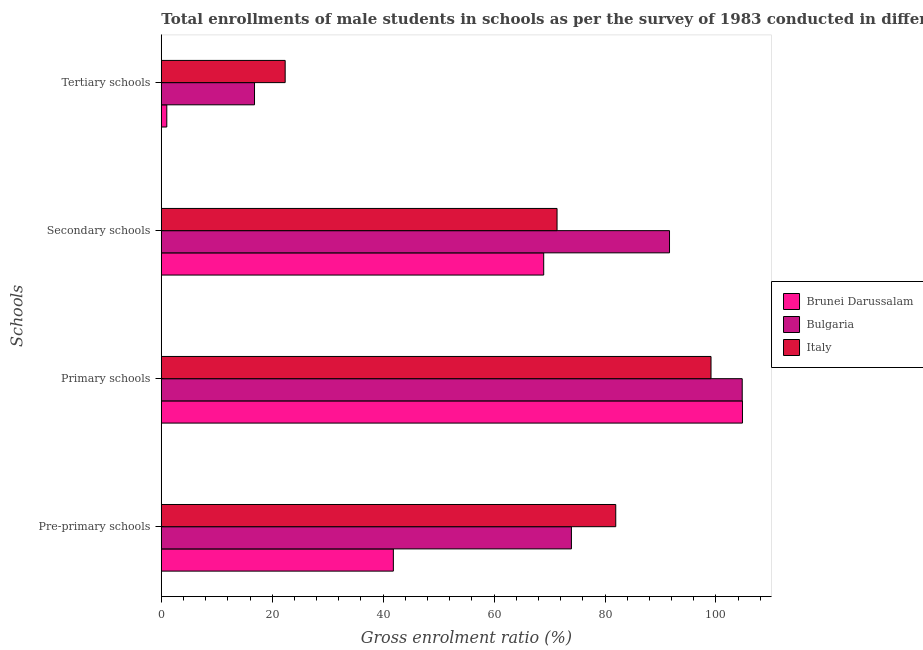Are the number of bars per tick equal to the number of legend labels?
Give a very brief answer. Yes. Are the number of bars on each tick of the Y-axis equal?
Your answer should be compact. Yes. How many bars are there on the 4th tick from the top?
Provide a short and direct response. 3. What is the label of the 4th group of bars from the top?
Your response must be concise. Pre-primary schools. What is the gross enrolment ratio(male) in tertiary schools in Brunei Darussalam?
Your response must be concise. 0.99. Across all countries, what is the maximum gross enrolment ratio(male) in pre-primary schools?
Make the answer very short. 81.93. Across all countries, what is the minimum gross enrolment ratio(male) in primary schools?
Your response must be concise. 99.11. In which country was the gross enrolment ratio(male) in primary schools maximum?
Your response must be concise. Brunei Darussalam. In which country was the gross enrolment ratio(male) in tertiary schools minimum?
Offer a very short reply. Brunei Darussalam. What is the total gross enrolment ratio(male) in tertiary schools in the graph?
Provide a succinct answer. 40.12. What is the difference between the gross enrolment ratio(male) in secondary schools in Brunei Darussalam and that in Bulgaria?
Provide a short and direct response. -22.68. What is the difference between the gross enrolment ratio(male) in primary schools in Brunei Darussalam and the gross enrolment ratio(male) in pre-primary schools in Bulgaria?
Your response must be concise. 30.84. What is the average gross enrolment ratio(male) in tertiary schools per country?
Offer a very short reply. 13.37. What is the difference between the gross enrolment ratio(male) in pre-primary schools and gross enrolment ratio(male) in secondary schools in Bulgaria?
Keep it short and to the point. -17.69. What is the ratio of the gross enrolment ratio(male) in tertiary schools in Brunei Darussalam to that in Bulgaria?
Your response must be concise. 0.06. What is the difference between the highest and the second highest gross enrolment ratio(male) in secondary schools?
Keep it short and to the point. 20.28. What is the difference between the highest and the lowest gross enrolment ratio(male) in primary schools?
Ensure brevity in your answer.  5.67. What does the 1st bar from the top in Pre-primary schools represents?
Provide a succinct answer. Italy. Is it the case that in every country, the sum of the gross enrolment ratio(male) in pre-primary schools and gross enrolment ratio(male) in primary schools is greater than the gross enrolment ratio(male) in secondary schools?
Offer a terse response. Yes. Are all the bars in the graph horizontal?
Provide a short and direct response. Yes. How many legend labels are there?
Offer a terse response. 3. What is the title of the graph?
Give a very brief answer. Total enrollments of male students in schools as per the survey of 1983 conducted in different countries. Does "Portugal" appear as one of the legend labels in the graph?
Offer a very short reply. No. What is the label or title of the Y-axis?
Your answer should be compact. Schools. What is the Gross enrolment ratio (%) of Brunei Darussalam in Pre-primary schools?
Provide a succinct answer. 41.84. What is the Gross enrolment ratio (%) of Bulgaria in Pre-primary schools?
Keep it short and to the point. 73.94. What is the Gross enrolment ratio (%) of Italy in Pre-primary schools?
Your answer should be very brief. 81.93. What is the Gross enrolment ratio (%) in Brunei Darussalam in Primary schools?
Give a very brief answer. 104.77. What is the Gross enrolment ratio (%) of Bulgaria in Primary schools?
Offer a terse response. 104.73. What is the Gross enrolment ratio (%) in Italy in Primary schools?
Make the answer very short. 99.11. What is the Gross enrolment ratio (%) in Brunei Darussalam in Secondary schools?
Ensure brevity in your answer.  68.94. What is the Gross enrolment ratio (%) of Bulgaria in Secondary schools?
Provide a succinct answer. 91.63. What is the Gross enrolment ratio (%) in Italy in Secondary schools?
Provide a succinct answer. 71.35. What is the Gross enrolment ratio (%) in Brunei Darussalam in Tertiary schools?
Your answer should be compact. 0.99. What is the Gross enrolment ratio (%) in Bulgaria in Tertiary schools?
Give a very brief answer. 16.8. What is the Gross enrolment ratio (%) in Italy in Tertiary schools?
Make the answer very short. 22.33. Across all Schools, what is the maximum Gross enrolment ratio (%) in Brunei Darussalam?
Give a very brief answer. 104.77. Across all Schools, what is the maximum Gross enrolment ratio (%) of Bulgaria?
Your response must be concise. 104.73. Across all Schools, what is the maximum Gross enrolment ratio (%) of Italy?
Make the answer very short. 99.11. Across all Schools, what is the minimum Gross enrolment ratio (%) in Brunei Darussalam?
Provide a succinct answer. 0.99. Across all Schools, what is the minimum Gross enrolment ratio (%) of Bulgaria?
Provide a short and direct response. 16.8. Across all Schools, what is the minimum Gross enrolment ratio (%) of Italy?
Keep it short and to the point. 22.33. What is the total Gross enrolment ratio (%) of Brunei Darussalam in the graph?
Offer a very short reply. 216.54. What is the total Gross enrolment ratio (%) in Bulgaria in the graph?
Give a very brief answer. 287.1. What is the total Gross enrolment ratio (%) of Italy in the graph?
Give a very brief answer. 274.72. What is the difference between the Gross enrolment ratio (%) in Brunei Darussalam in Pre-primary schools and that in Primary schools?
Offer a terse response. -62.94. What is the difference between the Gross enrolment ratio (%) in Bulgaria in Pre-primary schools and that in Primary schools?
Your response must be concise. -30.79. What is the difference between the Gross enrolment ratio (%) in Italy in Pre-primary schools and that in Primary schools?
Offer a very short reply. -17.18. What is the difference between the Gross enrolment ratio (%) of Brunei Darussalam in Pre-primary schools and that in Secondary schools?
Give a very brief answer. -27.1. What is the difference between the Gross enrolment ratio (%) in Bulgaria in Pre-primary schools and that in Secondary schools?
Offer a terse response. -17.69. What is the difference between the Gross enrolment ratio (%) of Italy in Pre-primary schools and that in Secondary schools?
Keep it short and to the point. 10.58. What is the difference between the Gross enrolment ratio (%) of Brunei Darussalam in Pre-primary schools and that in Tertiary schools?
Offer a very short reply. 40.85. What is the difference between the Gross enrolment ratio (%) of Bulgaria in Pre-primary schools and that in Tertiary schools?
Make the answer very short. 57.14. What is the difference between the Gross enrolment ratio (%) of Italy in Pre-primary schools and that in Tertiary schools?
Keep it short and to the point. 59.6. What is the difference between the Gross enrolment ratio (%) of Brunei Darussalam in Primary schools and that in Secondary schools?
Provide a succinct answer. 35.83. What is the difference between the Gross enrolment ratio (%) of Bulgaria in Primary schools and that in Secondary schools?
Give a very brief answer. 13.11. What is the difference between the Gross enrolment ratio (%) in Italy in Primary schools and that in Secondary schools?
Ensure brevity in your answer.  27.76. What is the difference between the Gross enrolment ratio (%) in Brunei Darussalam in Primary schools and that in Tertiary schools?
Offer a terse response. 103.79. What is the difference between the Gross enrolment ratio (%) of Bulgaria in Primary schools and that in Tertiary schools?
Your response must be concise. 87.93. What is the difference between the Gross enrolment ratio (%) of Italy in Primary schools and that in Tertiary schools?
Your answer should be compact. 76.78. What is the difference between the Gross enrolment ratio (%) of Brunei Darussalam in Secondary schools and that in Tertiary schools?
Provide a succinct answer. 67.95. What is the difference between the Gross enrolment ratio (%) in Bulgaria in Secondary schools and that in Tertiary schools?
Your response must be concise. 74.82. What is the difference between the Gross enrolment ratio (%) in Italy in Secondary schools and that in Tertiary schools?
Provide a short and direct response. 49.02. What is the difference between the Gross enrolment ratio (%) of Brunei Darussalam in Pre-primary schools and the Gross enrolment ratio (%) of Bulgaria in Primary schools?
Your answer should be compact. -62.9. What is the difference between the Gross enrolment ratio (%) of Brunei Darussalam in Pre-primary schools and the Gross enrolment ratio (%) of Italy in Primary schools?
Offer a terse response. -57.27. What is the difference between the Gross enrolment ratio (%) in Bulgaria in Pre-primary schools and the Gross enrolment ratio (%) in Italy in Primary schools?
Provide a short and direct response. -25.17. What is the difference between the Gross enrolment ratio (%) of Brunei Darussalam in Pre-primary schools and the Gross enrolment ratio (%) of Bulgaria in Secondary schools?
Your response must be concise. -49.79. What is the difference between the Gross enrolment ratio (%) of Brunei Darussalam in Pre-primary schools and the Gross enrolment ratio (%) of Italy in Secondary schools?
Your answer should be very brief. -29.51. What is the difference between the Gross enrolment ratio (%) in Bulgaria in Pre-primary schools and the Gross enrolment ratio (%) in Italy in Secondary schools?
Offer a very short reply. 2.59. What is the difference between the Gross enrolment ratio (%) of Brunei Darussalam in Pre-primary schools and the Gross enrolment ratio (%) of Bulgaria in Tertiary schools?
Provide a succinct answer. 25.03. What is the difference between the Gross enrolment ratio (%) of Brunei Darussalam in Pre-primary schools and the Gross enrolment ratio (%) of Italy in Tertiary schools?
Provide a succinct answer. 19.51. What is the difference between the Gross enrolment ratio (%) of Bulgaria in Pre-primary schools and the Gross enrolment ratio (%) of Italy in Tertiary schools?
Provide a short and direct response. 51.61. What is the difference between the Gross enrolment ratio (%) in Brunei Darussalam in Primary schools and the Gross enrolment ratio (%) in Bulgaria in Secondary schools?
Ensure brevity in your answer.  13.15. What is the difference between the Gross enrolment ratio (%) in Brunei Darussalam in Primary schools and the Gross enrolment ratio (%) in Italy in Secondary schools?
Provide a succinct answer. 33.43. What is the difference between the Gross enrolment ratio (%) in Bulgaria in Primary schools and the Gross enrolment ratio (%) in Italy in Secondary schools?
Your answer should be very brief. 33.38. What is the difference between the Gross enrolment ratio (%) in Brunei Darussalam in Primary schools and the Gross enrolment ratio (%) in Bulgaria in Tertiary schools?
Give a very brief answer. 87.97. What is the difference between the Gross enrolment ratio (%) in Brunei Darussalam in Primary schools and the Gross enrolment ratio (%) in Italy in Tertiary schools?
Give a very brief answer. 82.44. What is the difference between the Gross enrolment ratio (%) of Bulgaria in Primary schools and the Gross enrolment ratio (%) of Italy in Tertiary schools?
Your answer should be very brief. 82.4. What is the difference between the Gross enrolment ratio (%) of Brunei Darussalam in Secondary schools and the Gross enrolment ratio (%) of Bulgaria in Tertiary schools?
Keep it short and to the point. 52.14. What is the difference between the Gross enrolment ratio (%) of Brunei Darussalam in Secondary schools and the Gross enrolment ratio (%) of Italy in Tertiary schools?
Offer a very short reply. 46.61. What is the difference between the Gross enrolment ratio (%) in Bulgaria in Secondary schools and the Gross enrolment ratio (%) in Italy in Tertiary schools?
Provide a succinct answer. 69.29. What is the average Gross enrolment ratio (%) of Brunei Darussalam per Schools?
Your response must be concise. 54.14. What is the average Gross enrolment ratio (%) of Bulgaria per Schools?
Provide a short and direct response. 71.78. What is the average Gross enrolment ratio (%) in Italy per Schools?
Provide a succinct answer. 68.68. What is the difference between the Gross enrolment ratio (%) in Brunei Darussalam and Gross enrolment ratio (%) in Bulgaria in Pre-primary schools?
Make the answer very short. -32.1. What is the difference between the Gross enrolment ratio (%) in Brunei Darussalam and Gross enrolment ratio (%) in Italy in Pre-primary schools?
Ensure brevity in your answer.  -40.09. What is the difference between the Gross enrolment ratio (%) of Bulgaria and Gross enrolment ratio (%) of Italy in Pre-primary schools?
Provide a succinct answer. -7.99. What is the difference between the Gross enrolment ratio (%) in Brunei Darussalam and Gross enrolment ratio (%) in Bulgaria in Primary schools?
Keep it short and to the point. 0.04. What is the difference between the Gross enrolment ratio (%) of Brunei Darussalam and Gross enrolment ratio (%) of Italy in Primary schools?
Ensure brevity in your answer.  5.67. What is the difference between the Gross enrolment ratio (%) in Bulgaria and Gross enrolment ratio (%) in Italy in Primary schools?
Offer a very short reply. 5.63. What is the difference between the Gross enrolment ratio (%) in Brunei Darussalam and Gross enrolment ratio (%) in Bulgaria in Secondary schools?
Provide a short and direct response. -22.68. What is the difference between the Gross enrolment ratio (%) in Brunei Darussalam and Gross enrolment ratio (%) in Italy in Secondary schools?
Your response must be concise. -2.41. What is the difference between the Gross enrolment ratio (%) of Bulgaria and Gross enrolment ratio (%) of Italy in Secondary schools?
Keep it short and to the point. 20.28. What is the difference between the Gross enrolment ratio (%) in Brunei Darussalam and Gross enrolment ratio (%) in Bulgaria in Tertiary schools?
Offer a terse response. -15.81. What is the difference between the Gross enrolment ratio (%) in Brunei Darussalam and Gross enrolment ratio (%) in Italy in Tertiary schools?
Make the answer very short. -21.34. What is the difference between the Gross enrolment ratio (%) in Bulgaria and Gross enrolment ratio (%) in Italy in Tertiary schools?
Keep it short and to the point. -5.53. What is the ratio of the Gross enrolment ratio (%) of Brunei Darussalam in Pre-primary schools to that in Primary schools?
Offer a terse response. 0.4. What is the ratio of the Gross enrolment ratio (%) of Bulgaria in Pre-primary schools to that in Primary schools?
Provide a succinct answer. 0.71. What is the ratio of the Gross enrolment ratio (%) in Italy in Pre-primary schools to that in Primary schools?
Keep it short and to the point. 0.83. What is the ratio of the Gross enrolment ratio (%) in Brunei Darussalam in Pre-primary schools to that in Secondary schools?
Give a very brief answer. 0.61. What is the ratio of the Gross enrolment ratio (%) of Bulgaria in Pre-primary schools to that in Secondary schools?
Give a very brief answer. 0.81. What is the ratio of the Gross enrolment ratio (%) in Italy in Pre-primary schools to that in Secondary schools?
Provide a succinct answer. 1.15. What is the ratio of the Gross enrolment ratio (%) in Brunei Darussalam in Pre-primary schools to that in Tertiary schools?
Give a very brief answer. 42.33. What is the ratio of the Gross enrolment ratio (%) of Bulgaria in Pre-primary schools to that in Tertiary schools?
Give a very brief answer. 4.4. What is the ratio of the Gross enrolment ratio (%) of Italy in Pre-primary schools to that in Tertiary schools?
Ensure brevity in your answer.  3.67. What is the ratio of the Gross enrolment ratio (%) of Brunei Darussalam in Primary schools to that in Secondary schools?
Provide a short and direct response. 1.52. What is the ratio of the Gross enrolment ratio (%) in Bulgaria in Primary schools to that in Secondary schools?
Ensure brevity in your answer.  1.14. What is the ratio of the Gross enrolment ratio (%) of Italy in Primary schools to that in Secondary schools?
Give a very brief answer. 1.39. What is the ratio of the Gross enrolment ratio (%) of Brunei Darussalam in Primary schools to that in Tertiary schools?
Your answer should be compact. 106. What is the ratio of the Gross enrolment ratio (%) in Bulgaria in Primary schools to that in Tertiary schools?
Your response must be concise. 6.23. What is the ratio of the Gross enrolment ratio (%) in Italy in Primary schools to that in Tertiary schools?
Your response must be concise. 4.44. What is the ratio of the Gross enrolment ratio (%) of Brunei Darussalam in Secondary schools to that in Tertiary schools?
Provide a succinct answer. 69.75. What is the ratio of the Gross enrolment ratio (%) of Bulgaria in Secondary schools to that in Tertiary schools?
Your answer should be compact. 5.45. What is the ratio of the Gross enrolment ratio (%) in Italy in Secondary schools to that in Tertiary schools?
Your answer should be compact. 3.2. What is the difference between the highest and the second highest Gross enrolment ratio (%) of Brunei Darussalam?
Offer a terse response. 35.83. What is the difference between the highest and the second highest Gross enrolment ratio (%) in Bulgaria?
Provide a succinct answer. 13.11. What is the difference between the highest and the second highest Gross enrolment ratio (%) in Italy?
Your response must be concise. 17.18. What is the difference between the highest and the lowest Gross enrolment ratio (%) in Brunei Darussalam?
Provide a succinct answer. 103.79. What is the difference between the highest and the lowest Gross enrolment ratio (%) of Bulgaria?
Offer a terse response. 87.93. What is the difference between the highest and the lowest Gross enrolment ratio (%) in Italy?
Your answer should be very brief. 76.78. 